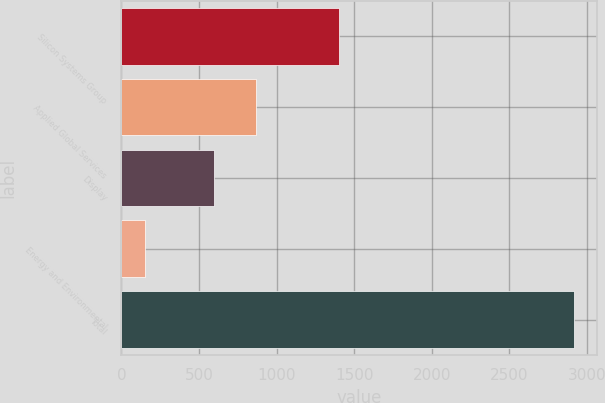Convert chart. <chart><loc_0><loc_0><loc_500><loc_500><bar_chart><fcel>Silicon Systems Group<fcel>Applied Global Services<fcel>Display<fcel>Energy and Environmental<fcel>Total<nl><fcel>1400<fcel>869.8<fcel>593<fcel>149<fcel>2917<nl></chart> 